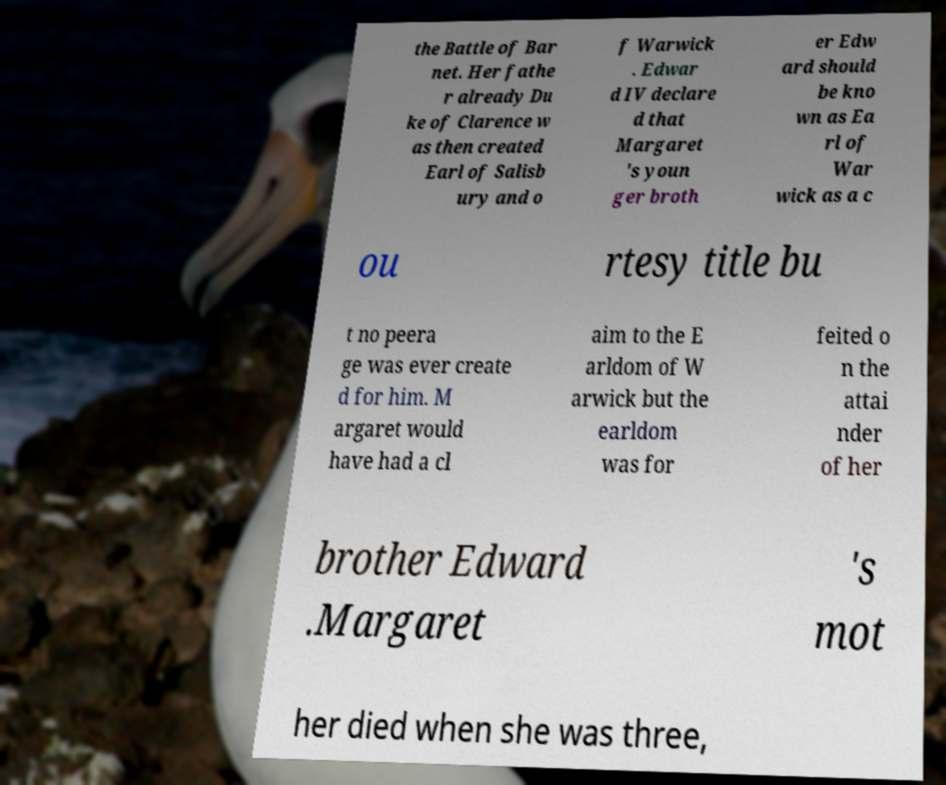What messages or text are displayed in this image? I need them in a readable, typed format. the Battle of Bar net. Her fathe r already Du ke of Clarence w as then created Earl of Salisb ury and o f Warwick . Edwar d IV declare d that Margaret 's youn ger broth er Edw ard should be kno wn as Ea rl of War wick as a c ou rtesy title bu t no peera ge was ever create d for him. M argaret would have had a cl aim to the E arldom of W arwick but the earldom was for feited o n the attai nder of her brother Edward .Margaret 's mot her died when she was three, 